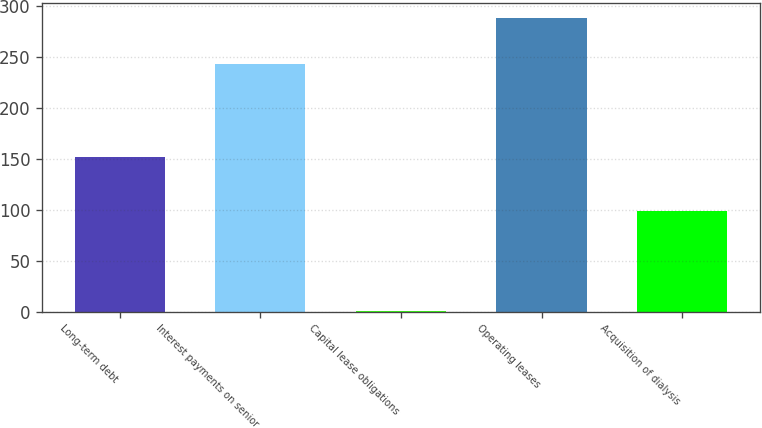Convert chart to OTSL. <chart><loc_0><loc_0><loc_500><loc_500><bar_chart><fcel>Long-term debt<fcel>Interest payments on senior<fcel>Capital lease obligations<fcel>Operating leases<fcel>Acquisition of dialysis<nl><fcel>152<fcel>243<fcel>1<fcel>288<fcel>99<nl></chart> 